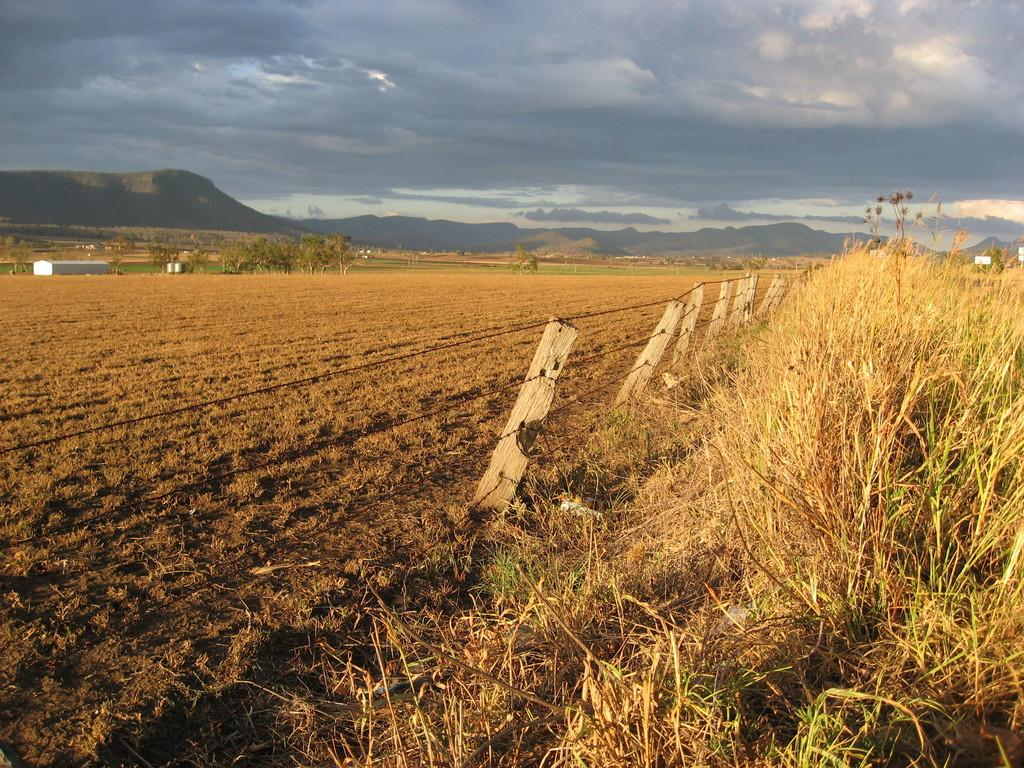What type of vegetation can be seen on the right side of the image? There is grass on the right side of the image. What type of structure is present in the image? There is fencing in the image. What is visible at the top of the image? The sky is visible at the top of the image. What type of ground is visible in the image? There is soil visible in the image. What type of natural feature can be seen in the image? There are trees in the image. Can you tell me how many threads are hanging from the trees in the image? There are no threads hanging from the trees in the image; only grass, fencing, sky, soil, and trees are present. 